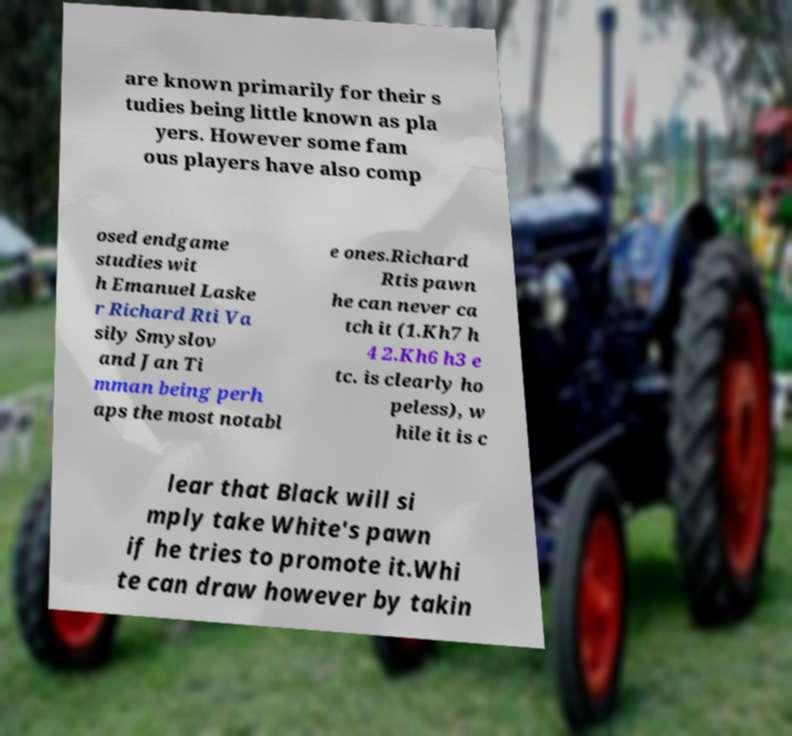Could you extract and type out the text from this image? are known primarily for their s tudies being little known as pla yers. However some fam ous players have also comp osed endgame studies wit h Emanuel Laske r Richard Rti Va sily Smyslov and Jan Ti mman being perh aps the most notabl e ones.Richard Rtis pawn he can never ca tch it (1.Kh7 h 4 2.Kh6 h3 e tc. is clearly ho peless), w hile it is c lear that Black will si mply take White's pawn if he tries to promote it.Whi te can draw however by takin 